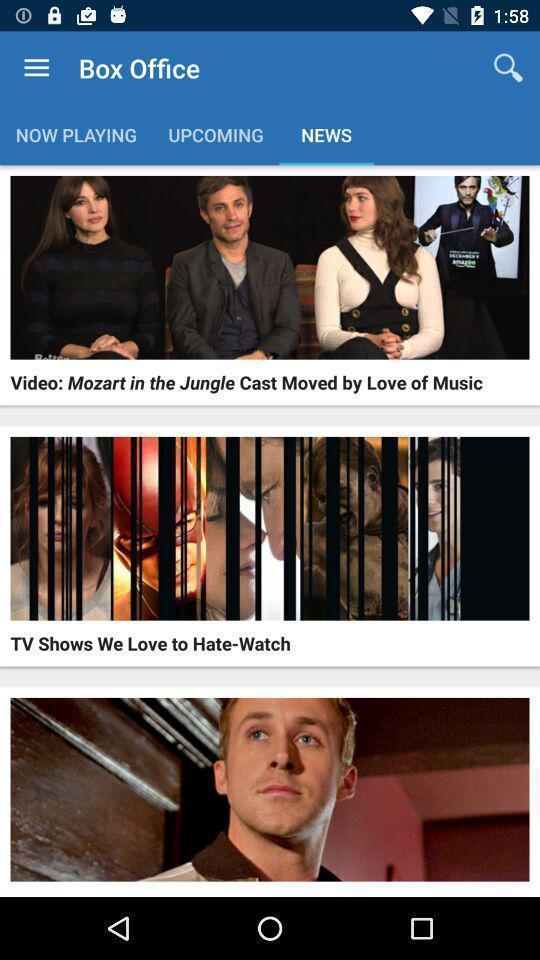Provide a description of this screenshot. Page showing different movie news in the movies app. 